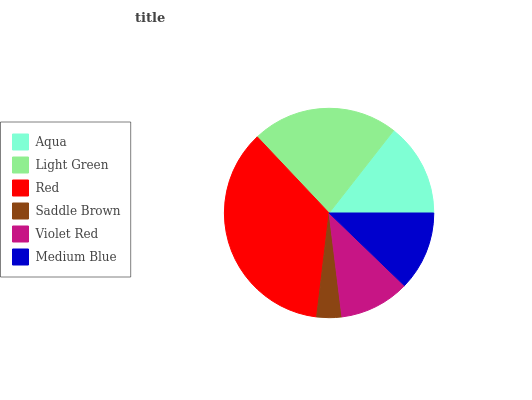Is Saddle Brown the minimum?
Answer yes or no. Yes. Is Red the maximum?
Answer yes or no. Yes. Is Light Green the minimum?
Answer yes or no. No. Is Light Green the maximum?
Answer yes or no. No. Is Light Green greater than Aqua?
Answer yes or no. Yes. Is Aqua less than Light Green?
Answer yes or no. Yes. Is Aqua greater than Light Green?
Answer yes or no. No. Is Light Green less than Aqua?
Answer yes or no. No. Is Aqua the high median?
Answer yes or no. Yes. Is Medium Blue the low median?
Answer yes or no. Yes. Is Red the high median?
Answer yes or no. No. Is Red the low median?
Answer yes or no. No. 